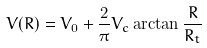Convert formula to latex. <formula><loc_0><loc_0><loc_500><loc_500>V ( R ) = V _ { 0 } + \frac { 2 } { \pi } V _ { c } \arctan { \frac { R } { R _ { t } } }</formula> 